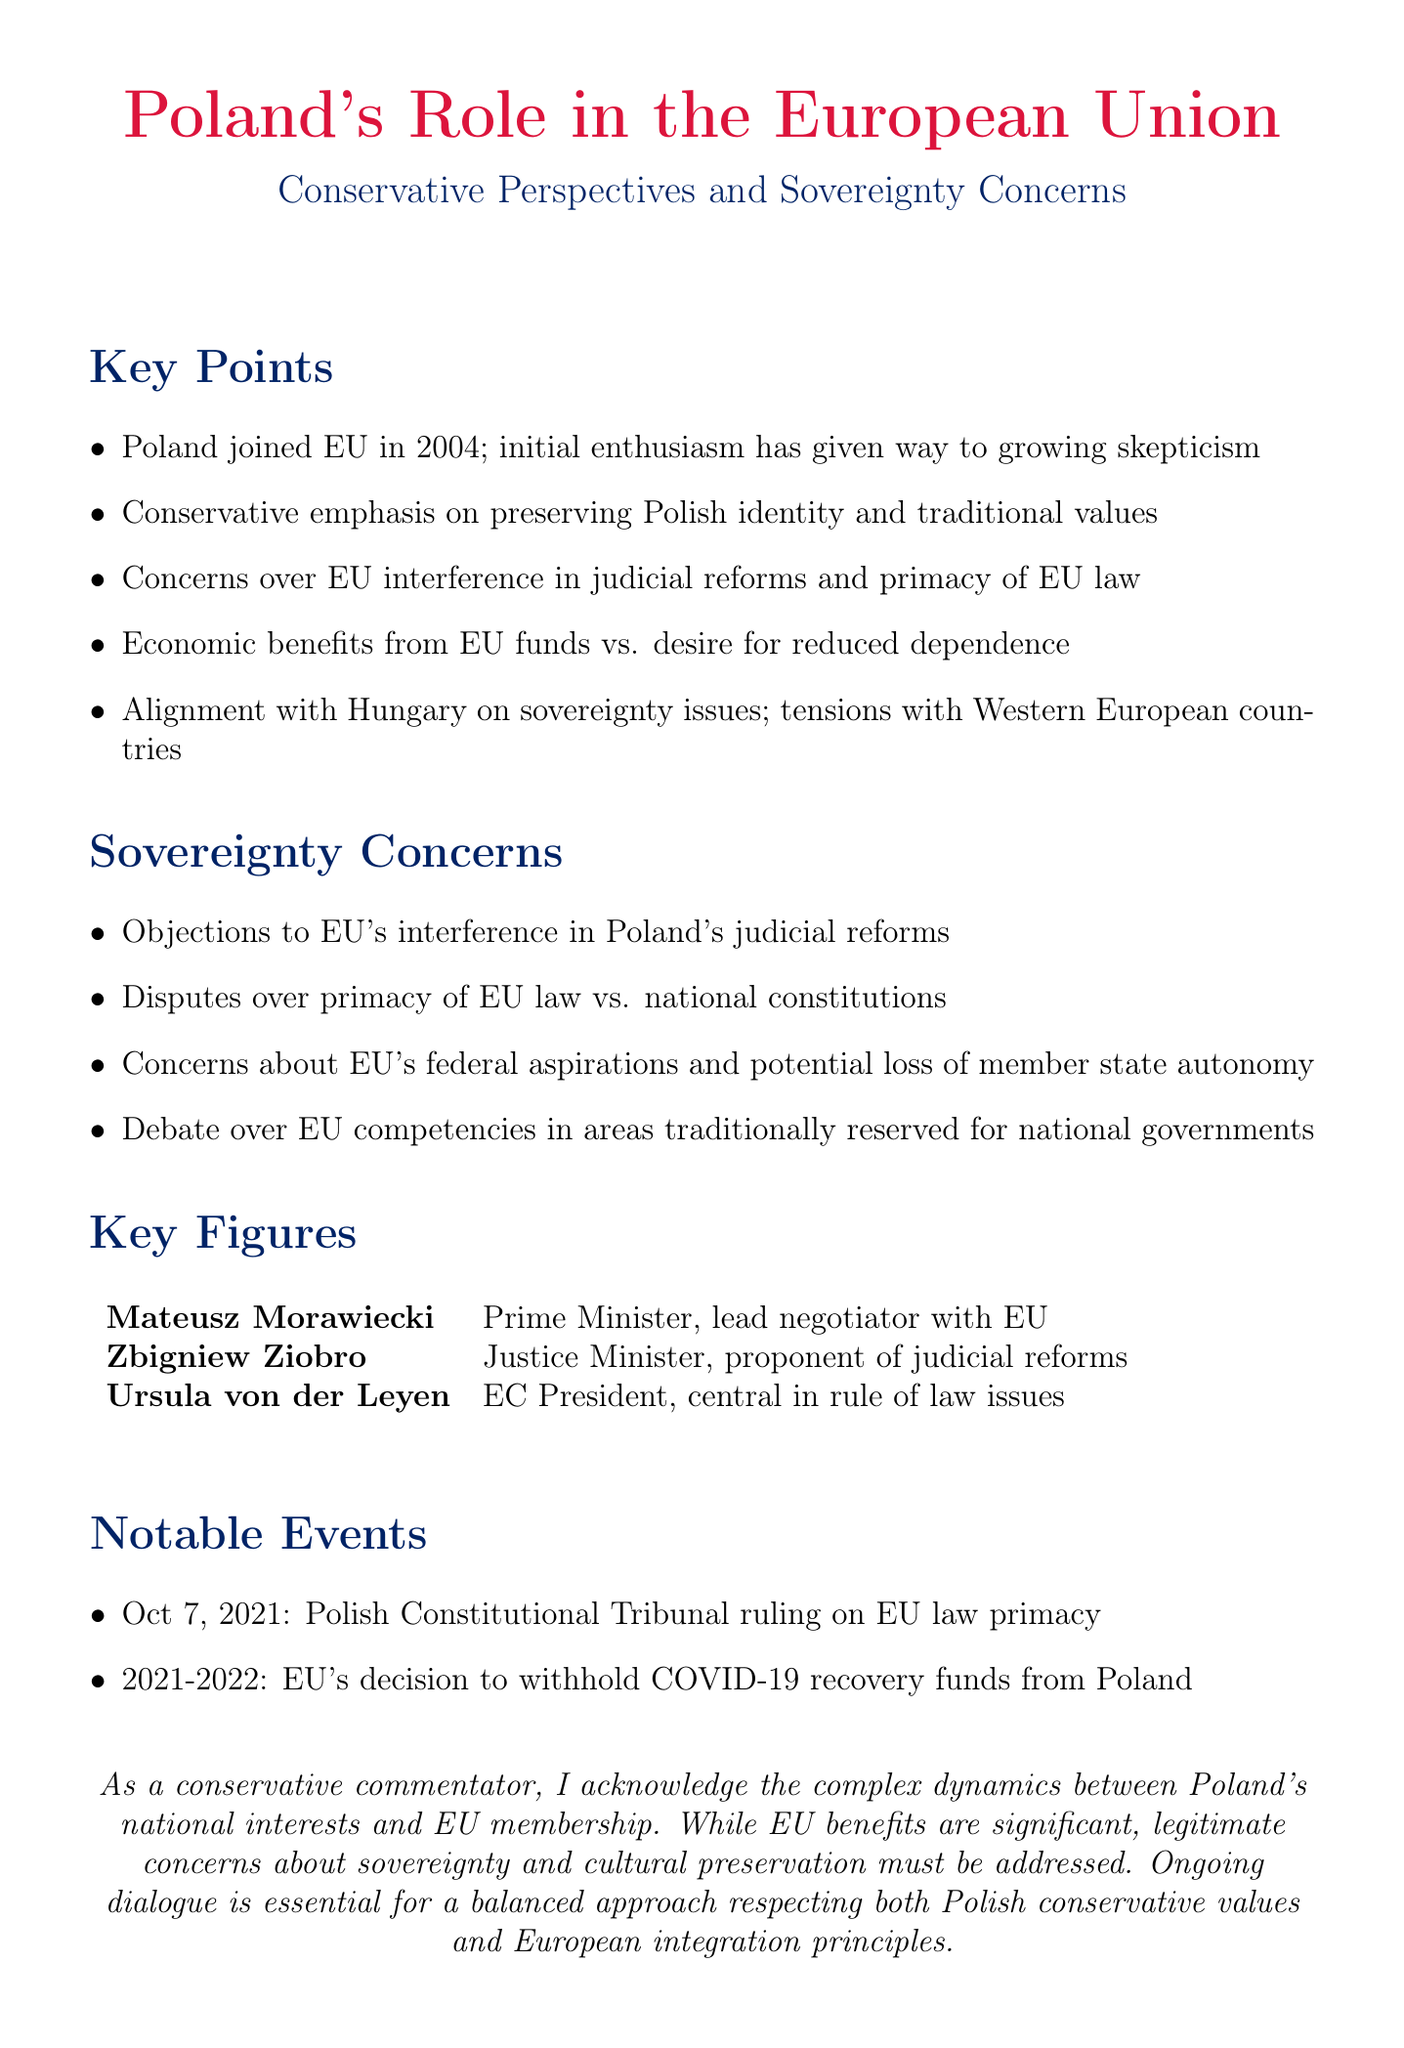What year did Poland join the EU? The memo states that Poland joined the EU in 2004 as part of the bloc's eastern expansion.
Answer: 2004 Who is the Prime Minister of Poland? The memo lists Mateusz Morawiecki as the Prime Minister of Poland and a leading figure in negotiations with the EU.
Answer: Mateusz Morawiecki What is the significance of the October 7, 2021 event? The memo states that this date marks the Polish Constitutional Tribunal ruling on EU law primacy, which challenged the supremacy of EU law over national legislation.
Answer: Challenged the supremacy of EU law What concept does Polish President Andrzej Duda promote? The memo mentions the support for a "Europe of Nations" concept advocated by Polish President Andrzej Duda.
Answer: Europe of Nations What concerns do conservatives have about adopting the Euro? The memo highlights concerns about losing monetary policy independence if Poland adopts the Euro.
Answer: Losing monetary policy independence What group has Poland formed in the European Parliament? The memo states that Poland has formed the European Conservatives and Reformists group in the European Parliament.
Answer: European Conservatives and Reformists What type of policies are resisted by Polish conservatives? The memo notes that Polish conservatives resist the EU's progressive social policies, such as LGBTQ+ rights.
Answer: Progressive social policies Which country does Poland align with on sovereignty issues? The memo states that Poland aligns with Hungary's Viktor Orbán on issues of sovereignty.
Answer: Hungary What is the overarching concern regarding EU's federal aspirations? The memo discusses concerns about potential loss of member state autonomy as a result of the EU's federal aspirations.
Answer: Loss of member state autonomy 